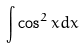Convert formula to latex. <formula><loc_0><loc_0><loc_500><loc_500>\int \cos ^ { 2 } x d x</formula> 